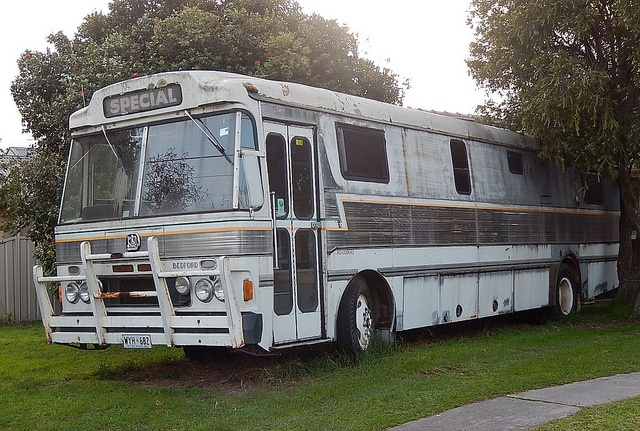Describe the objects in this image and their specific colors. I can see bus in white, darkgray, black, gray, and lightgray tones in this image. 